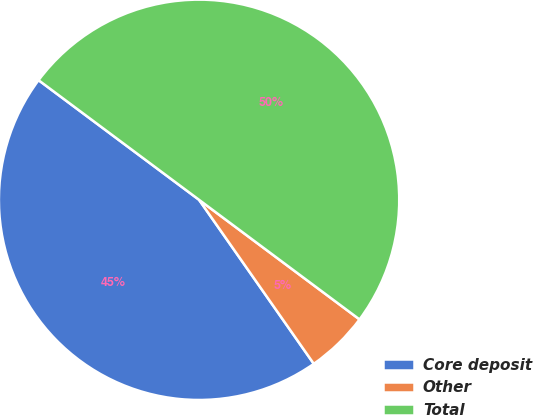Convert chart to OTSL. <chart><loc_0><loc_0><loc_500><loc_500><pie_chart><fcel>Core deposit<fcel>Other<fcel>Total<nl><fcel>44.91%<fcel>5.09%<fcel>50.0%<nl></chart> 